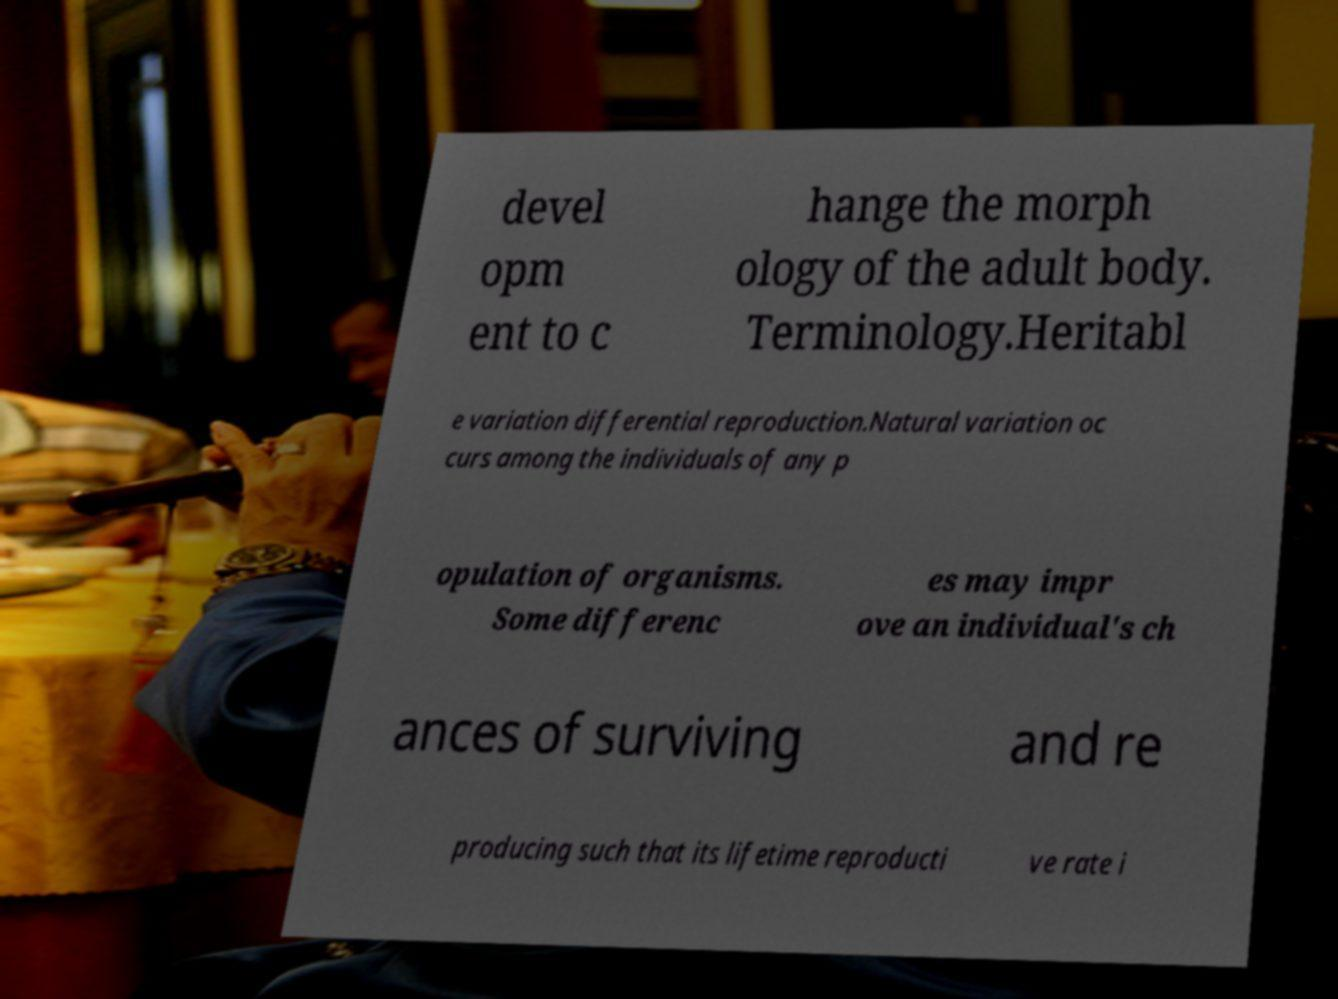There's text embedded in this image that I need extracted. Can you transcribe it verbatim? devel opm ent to c hange the morph ology of the adult body. Terminology.Heritabl e variation differential reproduction.Natural variation oc curs among the individuals of any p opulation of organisms. Some differenc es may impr ove an individual's ch ances of surviving and re producing such that its lifetime reproducti ve rate i 